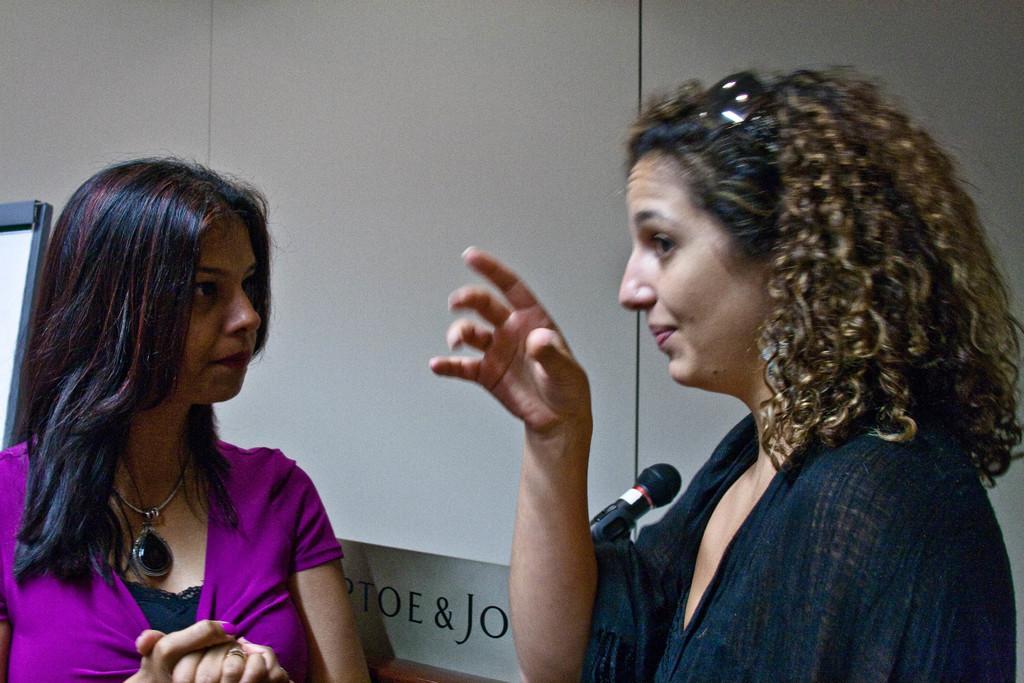Can you describe this image briefly? In the foreground of the picture there are two women standing, behind them it is wall. In the center there is a microphone. On the left there is a board. 